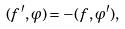Convert formula to latex. <formula><loc_0><loc_0><loc_500><loc_500>( f ^ { \prime } , \varphi ) = - ( f , \varphi ^ { \prime } ) ,</formula> 